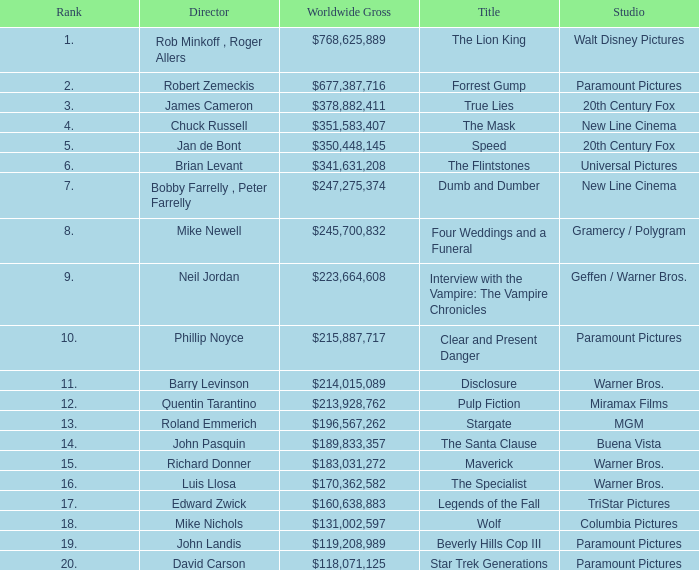What is the Worldwide Gross of the Film with a Rank of 3? $378,882,411. 